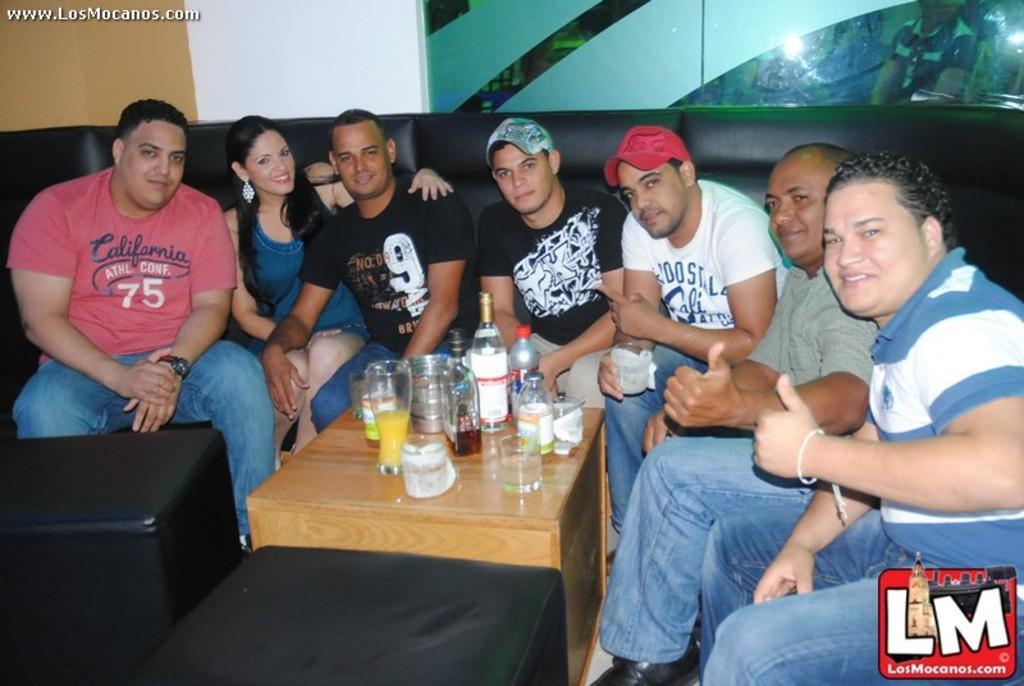How would you summarize this image in a sentence or two? There are seven members sitting on sofa. Out of which two are wearing a cap. One is red and one is sky blue. Out of seven members one is lady having a smile on her face. In the middle of the image, there is a table where glasses, bottle, juices are kept. At the end of the image bottom right, there is a logo written LM with building. There is a background with glass and in that one person is visible. 